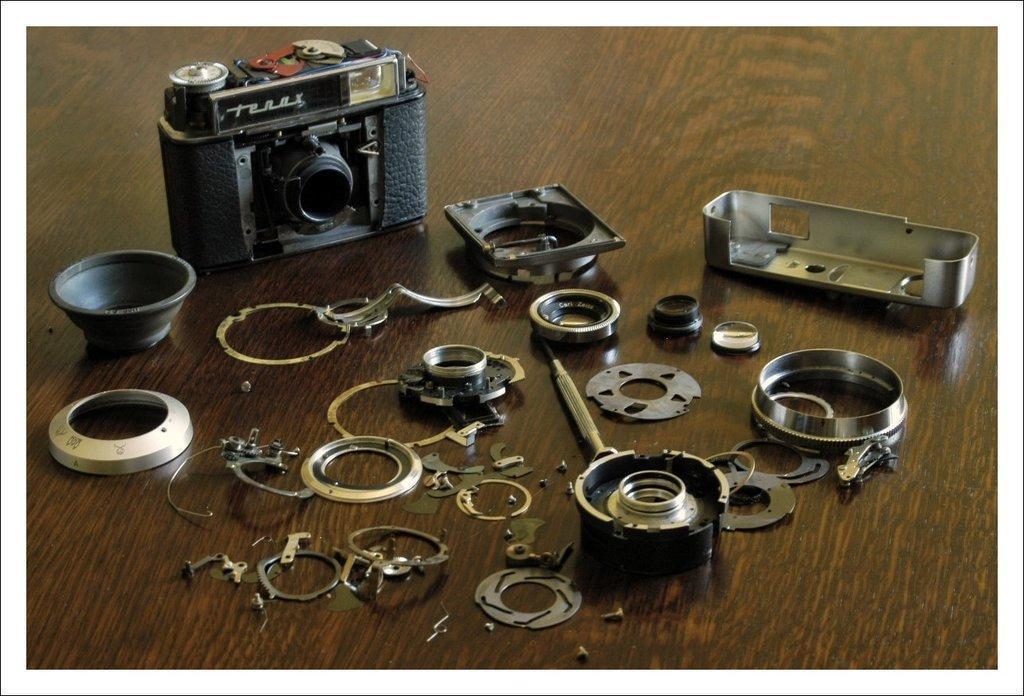Describe this image in one or two sentences. In this image there is a camera and few objects on the table. 